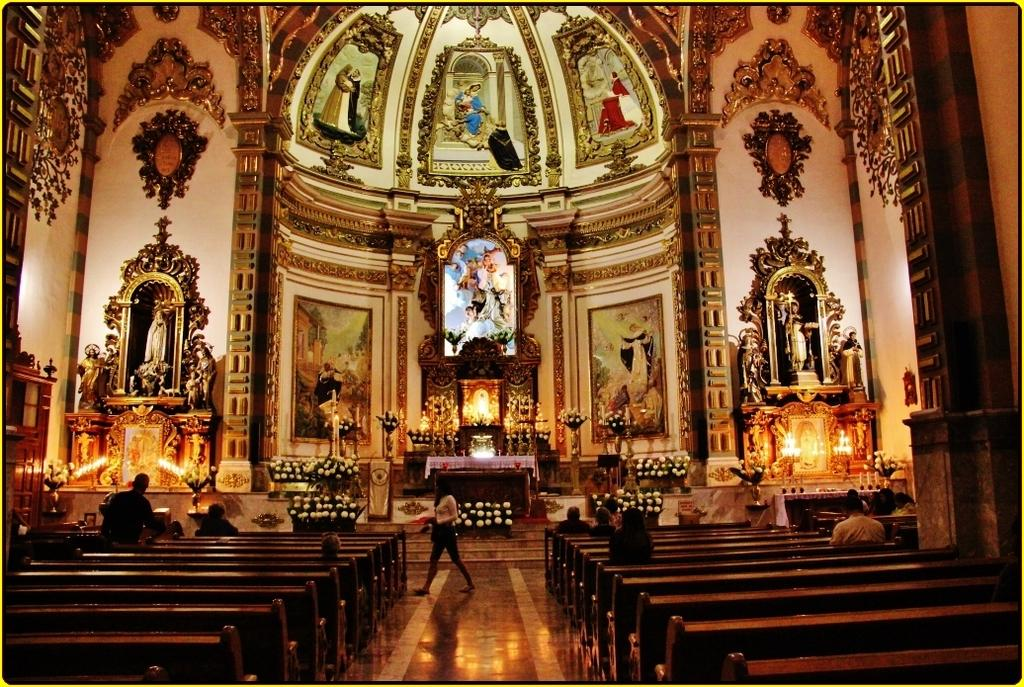What type of building is shown in the image? The image is an inside view of a church. What decorative elements can be seen in the image? There are sculptures in the image. What type of seating is available in the church? There are benches on the floor in the image. What other decorative elements can be seen in the image? There are flowers and candles in the image. What type of furniture is present in the image? There is a table in the image. What type of attraction can be seen in the pocket of the person in the image? There is no person or pocket visible in the image; it is an inside view of a church. 